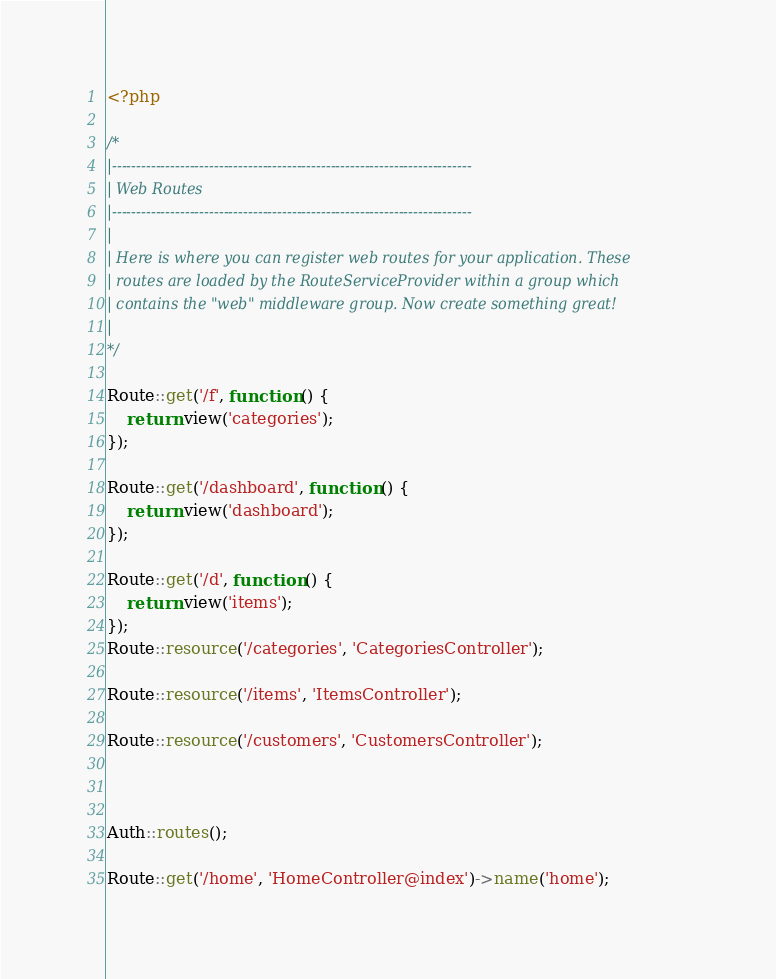Convert code to text. <code><loc_0><loc_0><loc_500><loc_500><_PHP_><?php

/*
|--------------------------------------------------------------------------
| Web Routes
|--------------------------------------------------------------------------
|
| Here is where you can register web routes for your application. These
| routes are loaded by the RouteServiceProvider within a group which
| contains the "web" middleware group. Now create something great!
|
*/

Route::get('/f', function () {
    return view('categories');
});

Route::get('/dashboard', function () {
    return view('dashboard');
});

Route::get('/d', function () {
    return view('items');
});
Route::resource('/categories', 'CategoriesController');

Route::resource('/items', 'ItemsController');

Route::resource('/customers', 'CustomersController');



Auth::routes();

Route::get('/home', 'HomeController@index')->name('home');
</code> 